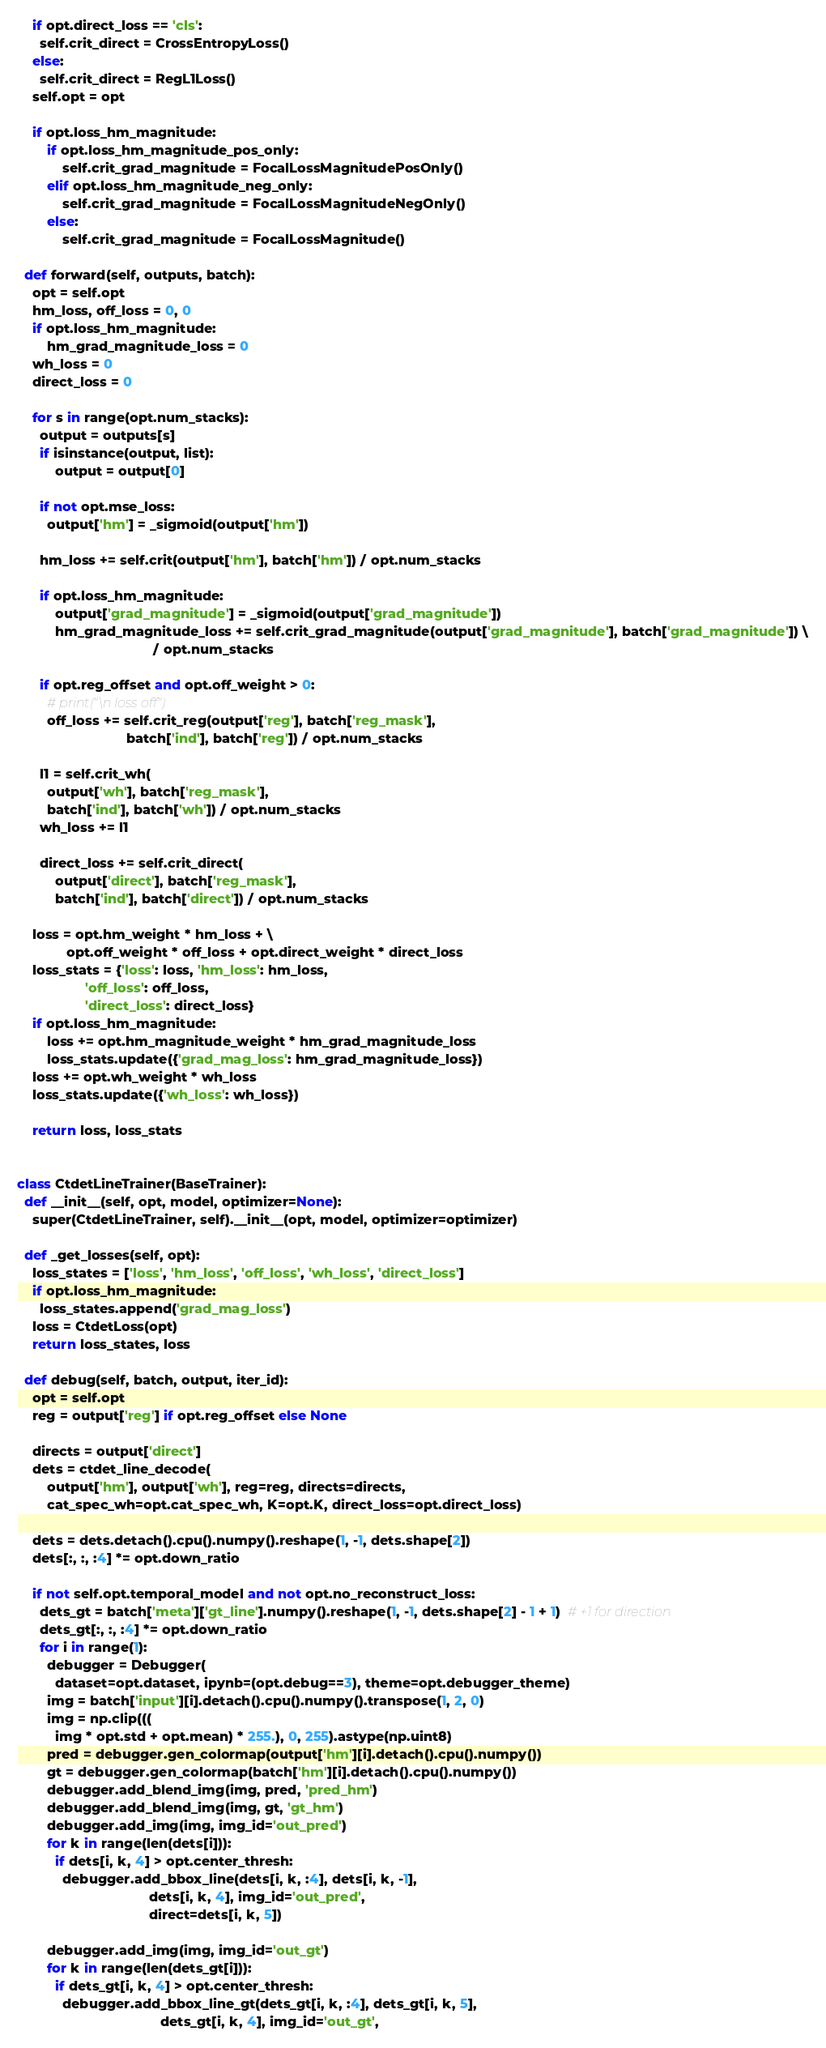<code> <loc_0><loc_0><loc_500><loc_500><_Python_>
    if opt.direct_loss == 'cls':
      self.crit_direct = CrossEntropyLoss()
    else:
      self.crit_direct = RegL1Loss()
    self.opt = opt

    if opt.loss_hm_magnitude:
        if opt.loss_hm_magnitude_pos_only:
            self.crit_grad_magnitude = FocalLossMagnitudePosOnly()
        elif opt.loss_hm_magnitude_neg_only:
            self.crit_grad_magnitude = FocalLossMagnitudeNegOnly()
        else:
            self.crit_grad_magnitude = FocalLossMagnitude()

  def forward(self, outputs, batch):
    opt = self.opt
    hm_loss, off_loss = 0, 0
    if opt.loss_hm_magnitude:
        hm_grad_magnitude_loss = 0
    wh_loss = 0
    direct_loss = 0

    for s in range(opt.num_stacks):
      output = outputs[s]
      if isinstance(output, list):
          output = output[0]

      if not opt.mse_loss:
        output['hm'] = _sigmoid(output['hm'])

      hm_loss += self.crit(output['hm'], batch['hm']) / opt.num_stacks

      if opt.loss_hm_magnitude:
          output['grad_magnitude'] = _sigmoid(output['grad_magnitude'])
          hm_grad_magnitude_loss += self.crit_grad_magnitude(output['grad_magnitude'], batch['grad_magnitude']) \
                                    / opt.num_stacks

      if opt.reg_offset and opt.off_weight > 0:
        # print("\n loss off")
        off_loss += self.crit_reg(output['reg'], batch['reg_mask'],
                             batch['ind'], batch['reg']) / opt.num_stacks
          
      l1 = self.crit_wh(
        output['wh'], batch['reg_mask'],
        batch['ind'], batch['wh']) / opt.num_stacks
      wh_loss += l1

      direct_loss += self.crit_direct(
          output['direct'], batch['reg_mask'],
          batch['ind'], batch['direct']) / opt.num_stacks

    loss = opt.hm_weight * hm_loss + \
             opt.off_weight * off_loss + opt.direct_weight * direct_loss
    loss_stats = {'loss': loss, 'hm_loss': hm_loss,
                  'off_loss': off_loss,
                  'direct_loss': direct_loss}
    if opt.loss_hm_magnitude:
        loss += opt.hm_magnitude_weight * hm_grad_magnitude_loss
        loss_stats.update({'grad_mag_loss': hm_grad_magnitude_loss})
    loss += opt.wh_weight * wh_loss
    loss_stats.update({'wh_loss': wh_loss})

    return loss, loss_stats


class CtdetLineTrainer(BaseTrainer):
  def __init__(self, opt, model, optimizer=None):
    super(CtdetLineTrainer, self).__init__(opt, model, optimizer=optimizer)

  def _get_losses(self, opt):
    loss_states = ['loss', 'hm_loss', 'off_loss', 'wh_loss', 'direct_loss']
    if opt.loss_hm_magnitude:
      loss_states.append('grad_mag_loss')
    loss = CtdetLoss(opt)
    return loss_states, loss

  def debug(self, batch, output, iter_id):
    opt = self.opt
    reg = output['reg'] if opt.reg_offset else None

    directs = output['direct']
    dets = ctdet_line_decode(
        output['hm'], output['wh'], reg=reg, directs=directs,
        cat_spec_wh=opt.cat_spec_wh, K=opt.K, direct_loss=opt.direct_loss)

    dets = dets.detach().cpu().numpy().reshape(1, -1, dets.shape[2])
    dets[:, :, :4] *= opt.down_ratio

    if not self.opt.temporal_model and not opt.no_reconstruct_loss:
      dets_gt = batch['meta']['gt_line'].numpy().reshape(1, -1, dets.shape[2] - 1 + 1)  # +1 for direction
      dets_gt[:, :, :4] *= opt.down_ratio
      for i in range(1):
        debugger = Debugger(
          dataset=opt.dataset, ipynb=(opt.debug==3), theme=opt.debugger_theme)
        img = batch['input'][i].detach().cpu().numpy().transpose(1, 2, 0)
        img = np.clip(((
          img * opt.std + opt.mean) * 255.), 0, 255).astype(np.uint8)
        pred = debugger.gen_colormap(output['hm'][i].detach().cpu().numpy())
        gt = debugger.gen_colormap(batch['hm'][i].detach().cpu().numpy())
        debugger.add_blend_img(img, pred, 'pred_hm')
        debugger.add_blend_img(img, gt, 'gt_hm')
        debugger.add_img(img, img_id='out_pred')
        for k in range(len(dets[i])):
          if dets[i, k, 4] > opt.center_thresh:
            debugger.add_bbox_line(dets[i, k, :4], dets[i, k, -1],
                                   dets[i, k, 4], img_id='out_pred',
                                   direct=dets[i, k, 5])

        debugger.add_img(img, img_id='out_gt')
        for k in range(len(dets_gt[i])):
          if dets_gt[i, k, 4] > opt.center_thresh:
            debugger.add_bbox_line_gt(dets_gt[i, k, :4], dets_gt[i, k, 5],
                                      dets_gt[i, k, 4], img_id='out_gt',</code> 